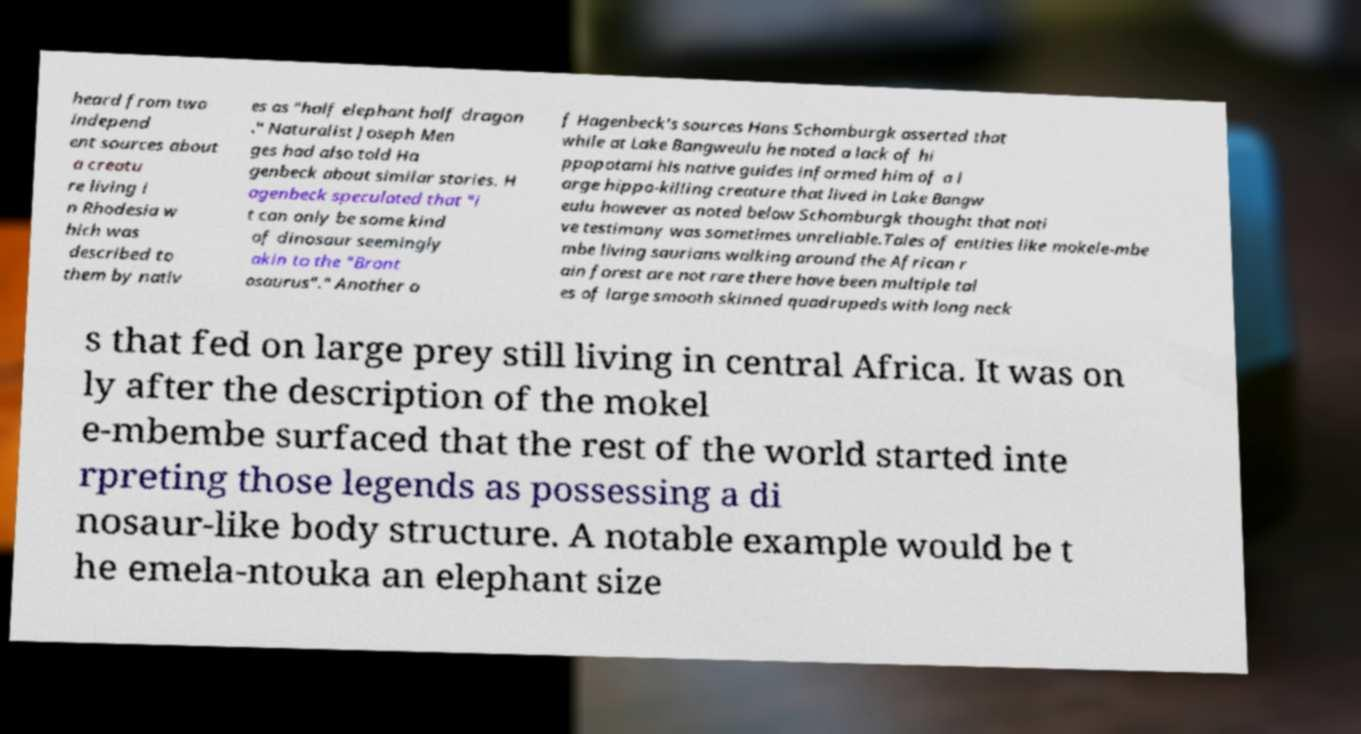For documentation purposes, I need the text within this image transcribed. Could you provide that? heard from two independ ent sources about a creatu re living i n Rhodesia w hich was described to them by nativ es as "half elephant half dragon ." Naturalist Joseph Men ges had also told Ha genbeck about similar stories. H agenbeck speculated that "i t can only be some kind of dinosaur seemingly akin to the "Bront osaurus"." Another o f Hagenbeck's sources Hans Schomburgk asserted that while at Lake Bangweulu he noted a lack of hi ppopotami his native guides informed him of a l arge hippo-killing creature that lived in Lake Bangw eulu however as noted below Schomburgk thought that nati ve testimony was sometimes unreliable.Tales of entities like mokele-mbe mbe living saurians walking around the African r ain forest are not rare there have been multiple tal es of large smooth skinned quadrupeds with long neck s that fed on large prey still living in central Africa. It was on ly after the description of the mokel e-mbembe surfaced that the rest of the world started inte rpreting those legends as possessing a di nosaur-like body structure. A notable example would be t he emela-ntouka an elephant size 